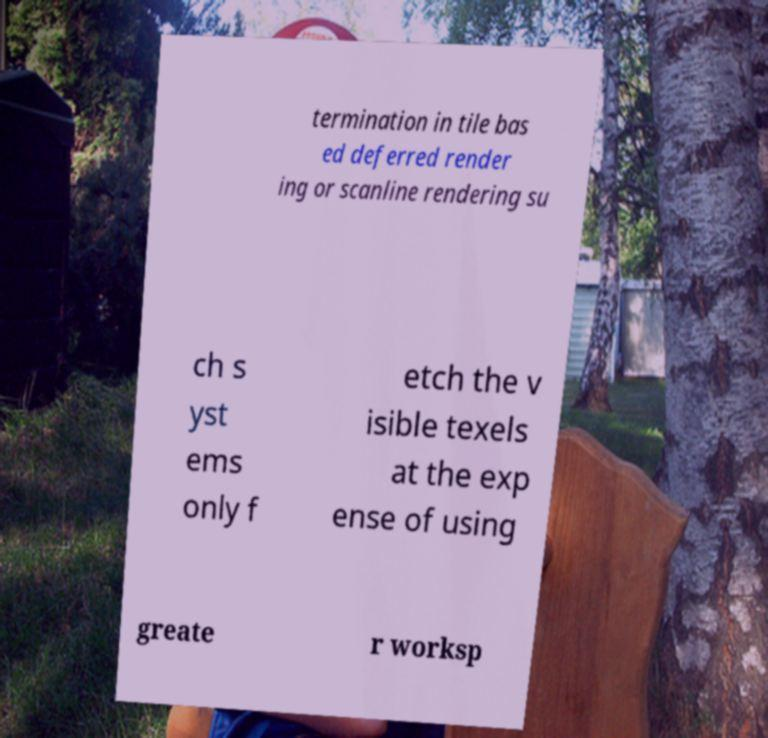Please identify and transcribe the text found in this image. termination in tile bas ed deferred render ing or scanline rendering su ch s yst ems only f etch the v isible texels at the exp ense of using greate r worksp 